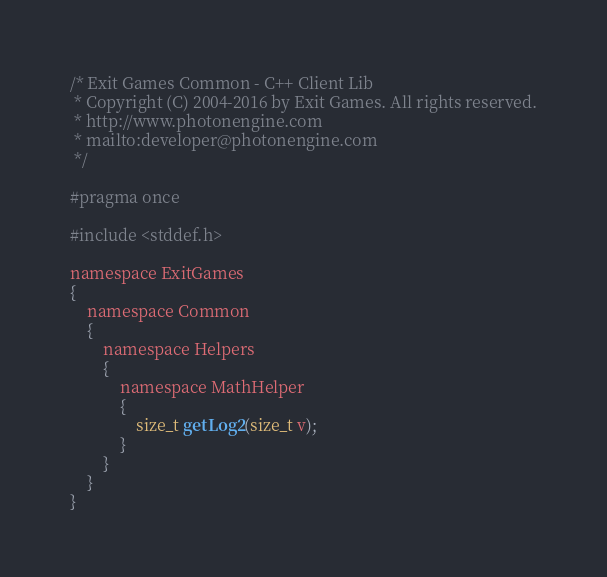<code> <loc_0><loc_0><loc_500><loc_500><_C_>/* Exit Games Common - C++ Client Lib
 * Copyright (C) 2004-2016 by Exit Games. All rights reserved.
 * http://www.photonengine.com
 * mailto:developer@photonengine.com
 */

#pragma once

#include <stddef.h>

namespace ExitGames
{
	namespace Common
	{
		namespace Helpers
		{
			namespace MathHelper
			{
				size_t getLog2(size_t v);
			}
		}
	}
}</code> 